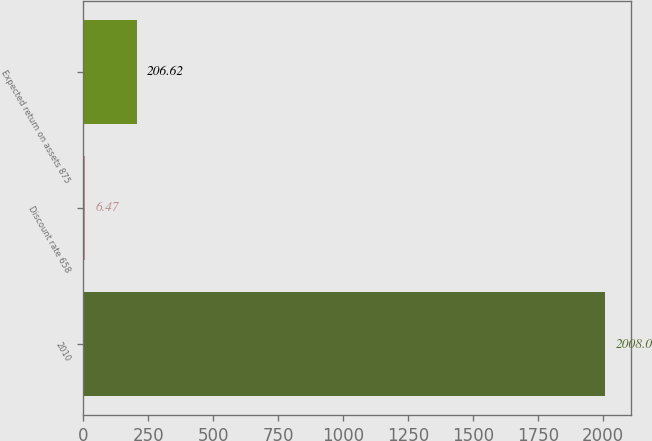<chart> <loc_0><loc_0><loc_500><loc_500><bar_chart><fcel>2010<fcel>Discount rate 658<fcel>Expected return on assets 875<nl><fcel>2008<fcel>6.47<fcel>206.62<nl></chart> 